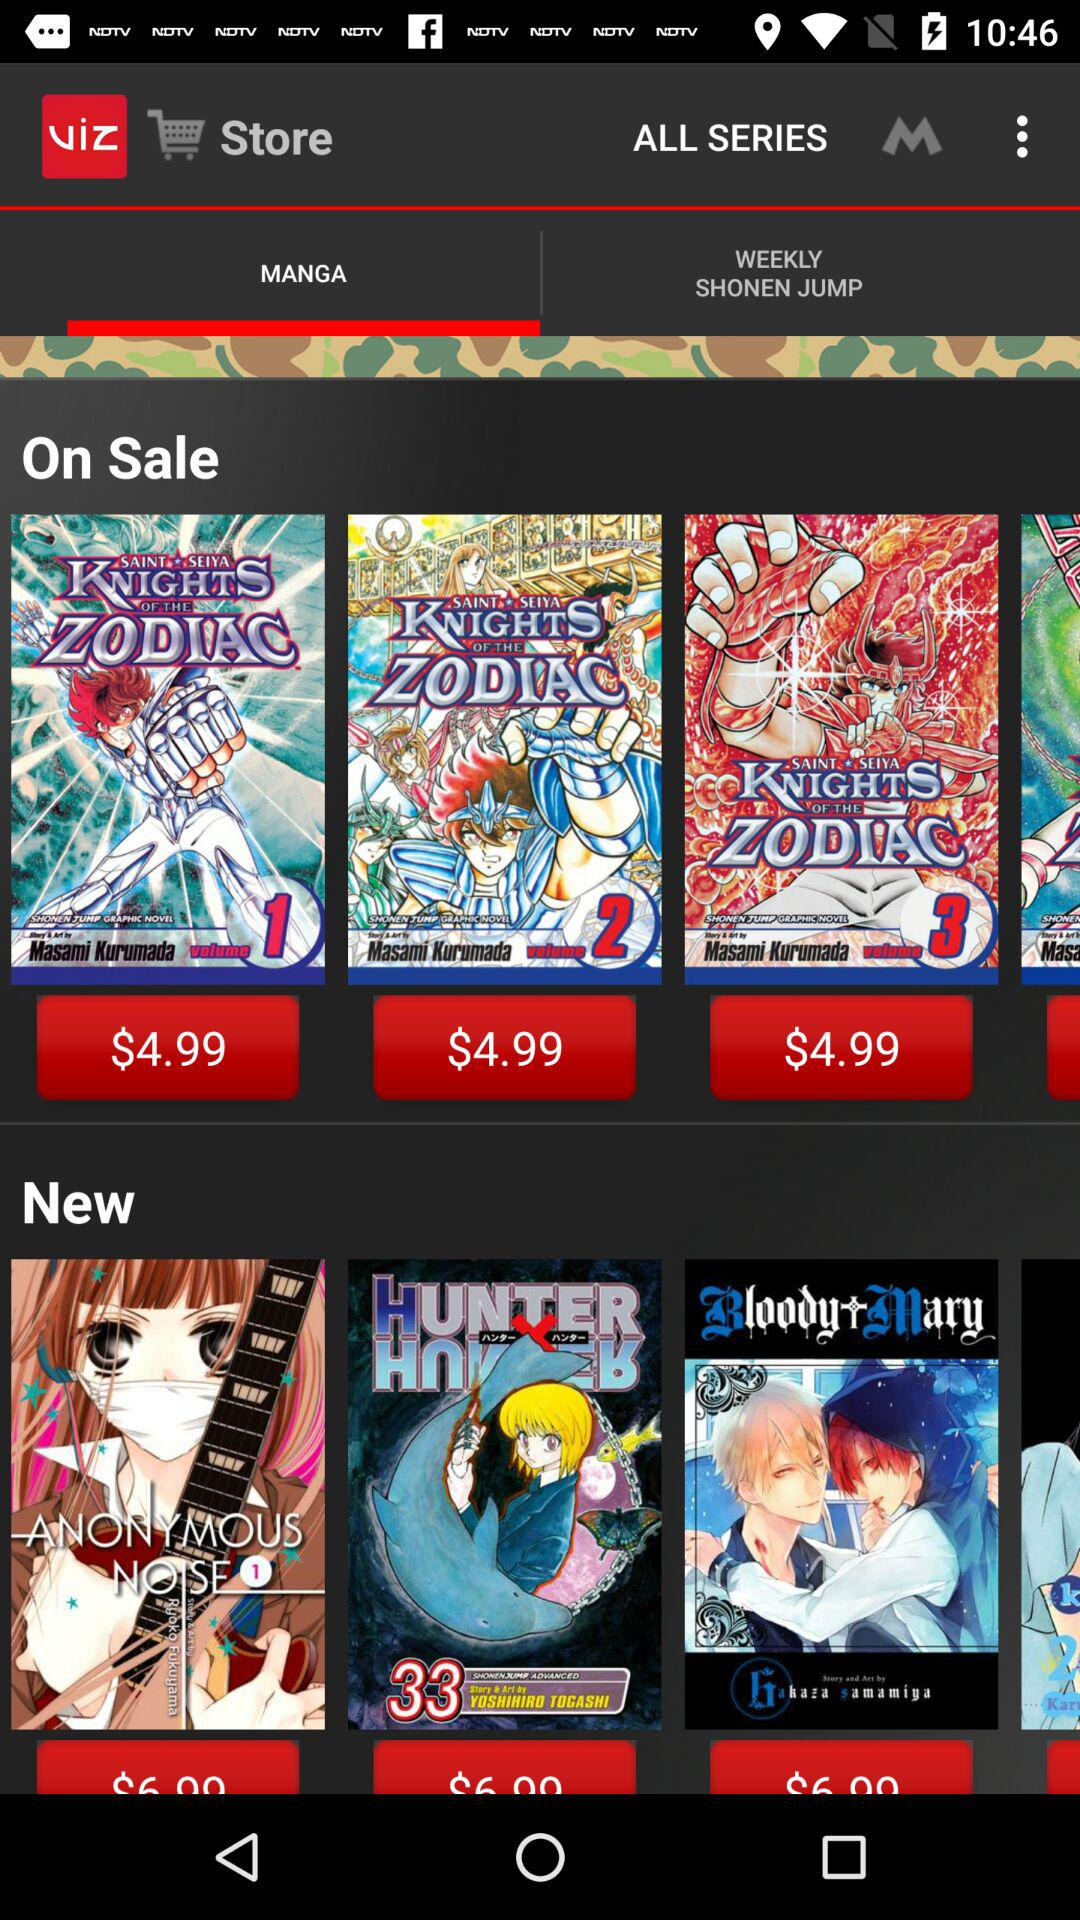What is the application name? The application name is "VIZ Manga". 